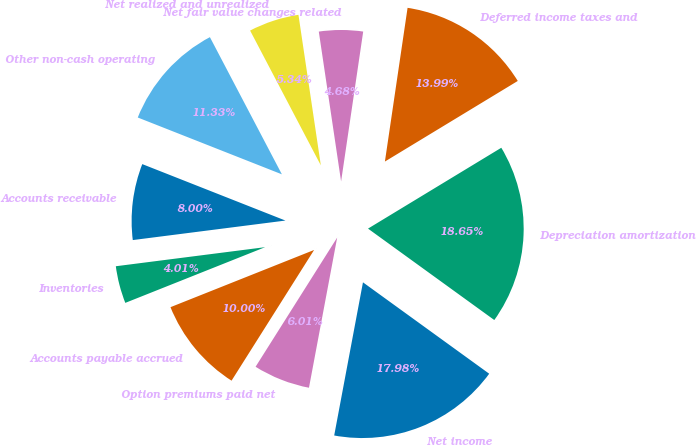Convert chart to OTSL. <chart><loc_0><loc_0><loc_500><loc_500><pie_chart><fcel>Net income<fcel>Depreciation amortization<fcel>Deferred income taxes and<fcel>Net fair value changes related<fcel>Net realized and unrealized<fcel>Other non-cash operating<fcel>Accounts receivable<fcel>Inventories<fcel>Accounts payable accrued<fcel>Option premiums paid net<nl><fcel>17.98%<fcel>18.65%<fcel>13.99%<fcel>4.68%<fcel>5.34%<fcel>11.33%<fcel>8.0%<fcel>4.01%<fcel>10.0%<fcel>6.01%<nl></chart> 